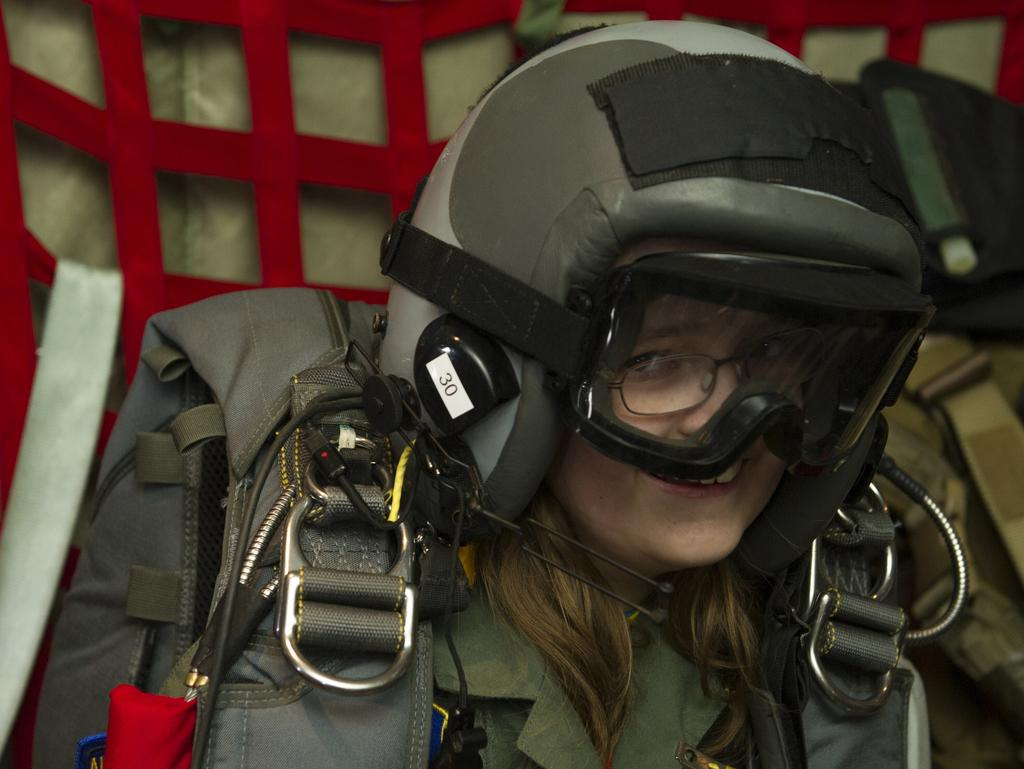What can be seen in the image? There is a person in the image. Can you describe the person's appearance? The person is wearing spectacles and a helmet. What else can be seen in the background of the image? There are other things visible in the background, but their specific details are not mentioned in the provided facts. What type of plant is growing on the person's thumb in the image? There is no plant growing on the person's thumb in the image, as the person is wearing a helmet and spectacles, and no mention of a thumb or plant is made in the provided facts. 